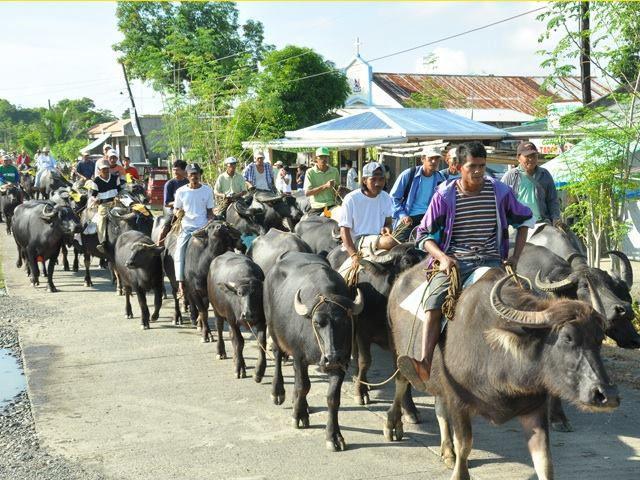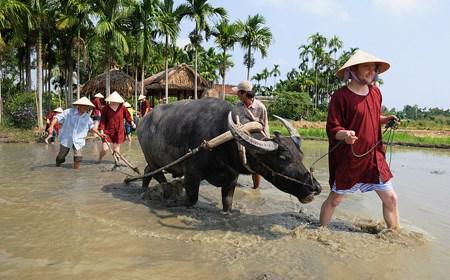The first image is the image on the left, the second image is the image on the right. Analyze the images presented: Is the assertion "An umbrella hovers over the cart in one of the images." valid? Answer yes or no. Yes. 